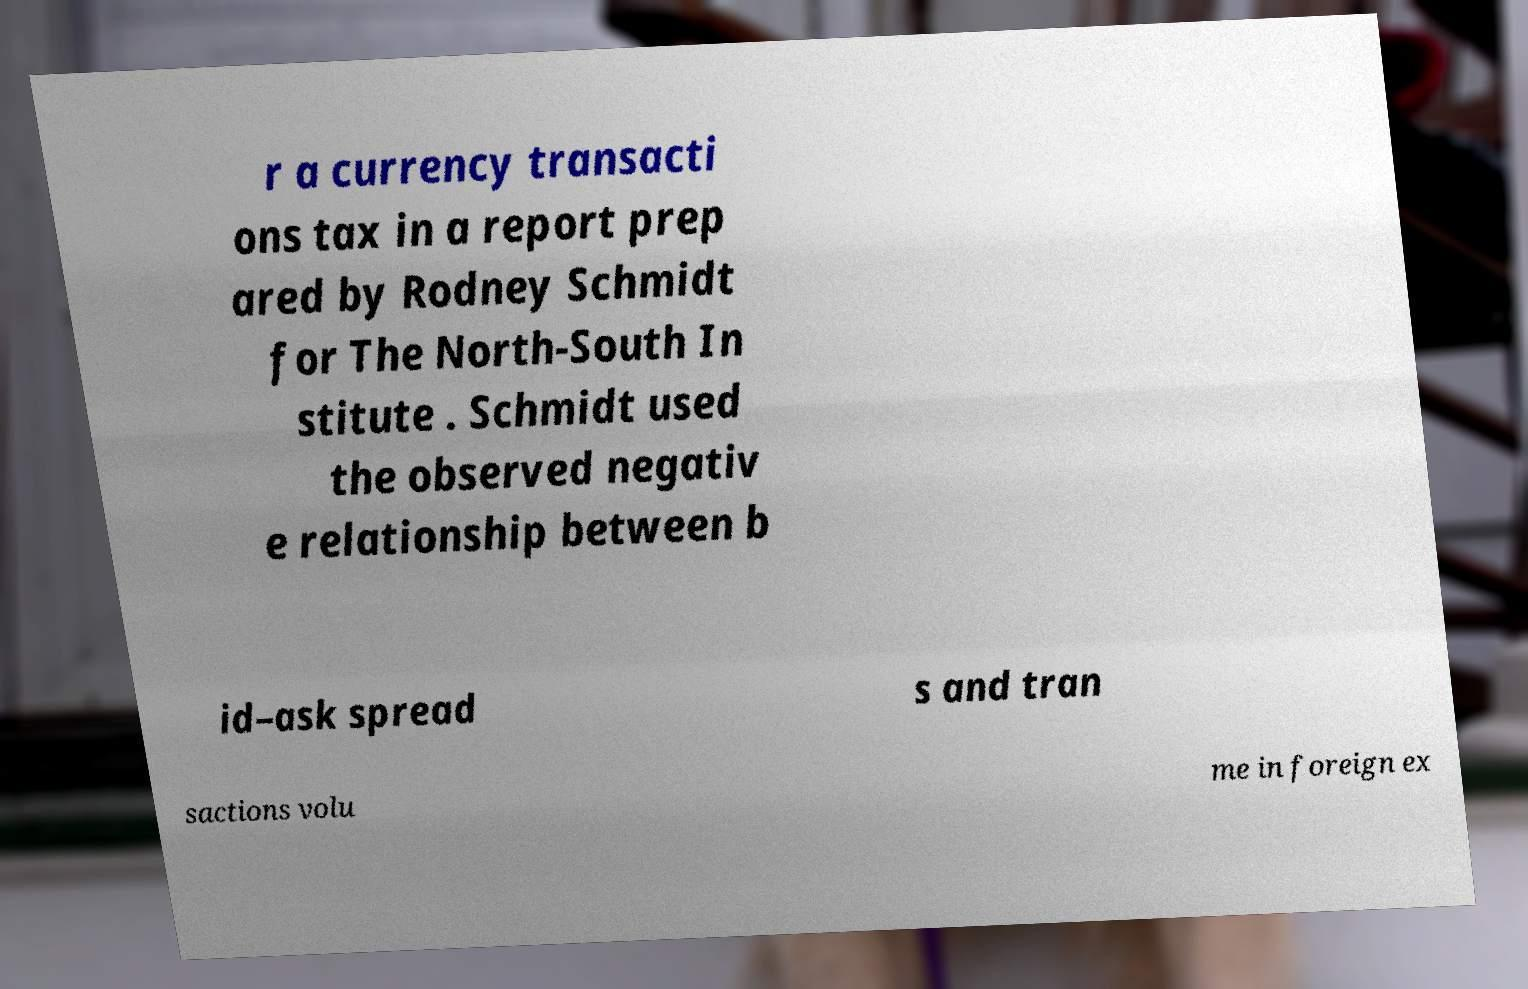Please read and relay the text visible in this image. What does it say? r a currency transacti ons tax in a report prep ared by Rodney Schmidt for The North-South In stitute . Schmidt used the observed negativ e relationship between b id–ask spread s and tran sactions volu me in foreign ex 